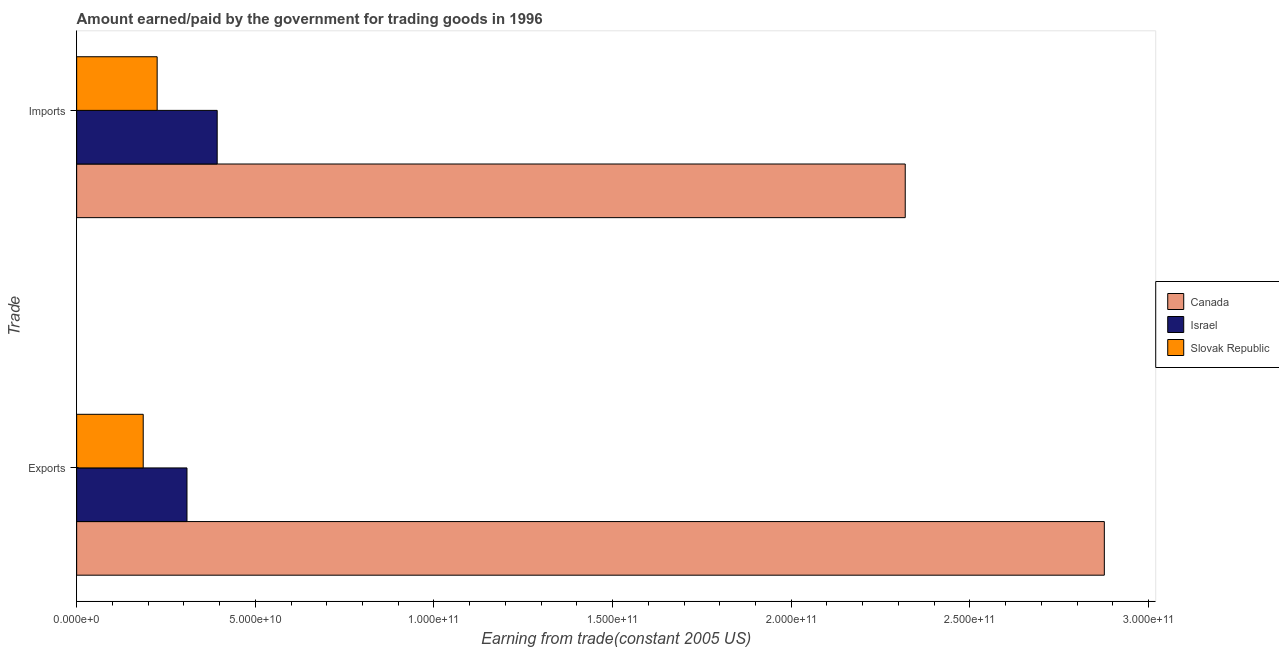How many different coloured bars are there?
Provide a succinct answer. 3. How many groups of bars are there?
Offer a terse response. 2. How many bars are there on the 2nd tick from the top?
Ensure brevity in your answer.  3. How many bars are there on the 2nd tick from the bottom?
Offer a very short reply. 3. What is the label of the 1st group of bars from the top?
Keep it short and to the point. Imports. What is the amount paid for imports in Slovak Republic?
Make the answer very short. 2.25e+1. Across all countries, what is the maximum amount earned from exports?
Keep it short and to the point. 2.88e+11. Across all countries, what is the minimum amount earned from exports?
Your response must be concise. 1.86e+1. In which country was the amount paid for imports maximum?
Keep it short and to the point. Canada. In which country was the amount paid for imports minimum?
Make the answer very short. Slovak Republic. What is the total amount earned from exports in the graph?
Offer a terse response. 3.37e+11. What is the difference between the amount earned from exports in Slovak Republic and that in Israel?
Make the answer very short. -1.23e+1. What is the difference between the amount paid for imports in Slovak Republic and the amount earned from exports in Canada?
Your answer should be compact. -2.65e+11. What is the average amount paid for imports per country?
Give a very brief answer. 9.79e+1. What is the difference between the amount earned from exports and amount paid for imports in Israel?
Give a very brief answer. -8.46e+09. In how many countries, is the amount earned from exports greater than 220000000000 US$?
Ensure brevity in your answer.  1. What is the ratio of the amount earned from exports in Canada to that in Israel?
Provide a succinct answer. 9.32. Is the amount paid for imports in Slovak Republic less than that in Canada?
Provide a short and direct response. Yes. What does the 1st bar from the top in Imports represents?
Offer a terse response. Slovak Republic. Does the graph contain any zero values?
Provide a short and direct response. No. Does the graph contain grids?
Give a very brief answer. No. How many legend labels are there?
Offer a terse response. 3. What is the title of the graph?
Give a very brief answer. Amount earned/paid by the government for trading goods in 1996. Does "Uruguay" appear as one of the legend labels in the graph?
Offer a terse response. No. What is the label or title of the X-axis?
Ensure brevity in your answer.  Earning from trade(constant 2005 US). What is the label or title of the Y-axis?
Ensure brevity in your answer.  Trade. What is the Earning from trade(constant 2005 US) in Canada in Exports?
Offer a very short reply. 2.88e+11. What is the Earning from trade(constant 2005 US) of Israel in Exports?
Ensure brevity in your answer.  3.09e+1. What is the Earning from trade(constant 2005 US) of Slovak Republic in Exports?
Your answer should be very brief. 1.86e+1. What is the Earning from trade(constant 2005 US) in Canada in Imports?
Offer a very short reply. 2.32e+11. What is the Earning from trade(constant 2005 US) of Israel in Imports?
Ensure brevity in your answer.  3.93e+1. What is the Earning from trade(constant 2005 US) in Slovak Republic in Imports?
Give a very brief answer. 2.25e+1. Across all Trade, what is the maximum Earning from trade(constant 2005 US) of Canada?
Provide a short and direct response. 2.88e+11. Across all Trade, what is the maximum Earning from trade(constant 2005 US) in Israel?
Provide a succinct answer. 3.93e+1. Across all Trade, what is the maximum Earning from trade(constant 2005 US) of Slovak Republic?
Your response must be concise. 2.25e+1. Across all Trade, what is the minimum Earning from trade(constant 2005 US) in Canada?
Provide a short and direct response. 2.32e+11. Across all Trade, what is the minimum Earning from trade(constant 2005 US) of Israel?
Keep it short and to the point. 3.09e+1. Across all Trade, what is the minimum Earning from trade(constant 2005 US) of Slovak Republic?
Your answer should be compact. 1.86e+1. What is the total Earning from trade(constant 2005 US) of Canada in the graph?
Provide a succinct answer. 5.20e+11. What is the total Earning from trade(constant 2005 US) in Israel in the graph?
Provide a short and direct response. 7.02e+1. What is the total Earning from trade(constant 2005 US) of Slovak Republic in the graph?
Your response must be concise. 4.12e+1. What is the difference between the Earning from trade(constant 2005 US) in Canada in Exports and that in Imports?
Offer a very short reply. 5.57e+1. What is the difference between the Earning from trade(constant 2005 US) in Israel in Exports and that in Imports?
Ensure brevity in your answer.  -8.46e+09. What is the difference between the Earning from trade(constant 2005 US) of Slovak Republic in Exports and that in Imports?
Offer a very short reply. -3.90e+09. What is the difference between the Earning from trade(constant 2005 US) in Canada in Exports and the Earning from trade(constant 2005 US) in Israel in Imports?
Make the answer very short. 2.48e+11. What is the difference between the Earning from trade(constant 2005 US) of Canada in Exports and the Earning from trade(constant 2005 US) of Slovak Republic in Imports?
Ensure brevity in your answer.  2.65e+11. What is the difference between the Earning from trade(constant 2005 US) of Israel in Exports and the Earning from trade(constant 2005 US) of Slovak Republic in Imports?
Your answer should be very brief. 8.35e+09. What is the average Earning from trade(constant 2005 US) of Canada per Trade?
Your answer should be very brief. 2.60e+11. What is the average Earning from trade(constant 2005 US) in Israel per Trade?
Make the answer very short. 3.51e+1. What is the average Earning from trade(constant 2005 US) in Slovak Republic per Trade?
Give a very brief answer. 2.06e+1. What is the difference between the Earning from trade(constant 2005 US) in Canada and Earning from trade(constant 2005 US) in Israel in Exports?
Ensure brevity in your answer.  2.57e+11. What is the difference between the Earning from trade(constant 2005 US) in Canada and Earning from trade(constant 2005 US) in Slovak Republic in Exports?
Ensure brevity in your answer.  2.69e+11. What is the difference between the Earning from trade(constant 2005 US) of Israel and Earning from trade(constant 2005 US) of Slovak Republic in Exports?
Offer a terse response. 1.23e+1. What is the difference between the Earning from trade(constant 2005 US) in Canada and Earning from trade(constant 2005 US) in Israel in Imports?
Give a very brief answer. 1.93e+11. What is the difference between the Earning from trade(constant 2005 US) in Canada and Earning from trade(constant 2005 US) in Slovak Republic in Imports?
Provide a short and direct response. 2.09e+11. What is the difference between the Earning from trade(constant 2005 US) of Israel and Earning from trade(constant 2005 US) of Slovak Republic in Imports?
Offer a very short reply. 1.68e+1. What is the ratio of the Earning from trade(constant 2005 US) of Canada in Exports to that in Imports?
Your answer should be compact. 1.24. What is the ratio of the Earning from trade(constant 2005 US) in Israel in Exports to that in Imports?
Provide a short and direct response. 0.79. What is the ratio of the Earning from trade(constant 2005 US) of Slovak Republic in Exports to that in Imports?
Your response must be concise. 0.83. What is the difference between the highest and the second highest Earning from trade(constant 2005 US) in Canada?
Provide a succinct answer. 5.57e+1. What is the difference between the highest and the second highest Earning from trade(constant 2005 US) of Israel?
Your response must be concise. 8.46e+09. What is the difference between the highest and the second highest Earning from trade(constant 2005 US) in Slovak Republic?
Your response must be concise. 3.90e+09. What is the difference between the highest and the lowest Earning from trade(constant 2005 US) of Canada?
Offer a very short reply. 5.57e+1. What is the difference between the highest and the lowest Earning from trade(constant 2005 US) of Israel?
Keep it short and to the point. 8.46e+09. What is the difference between the highest and the lowest Earning from trade(constant 2005 US) in Slovak Republic?
Your response must be concise. 3.90e+09. 